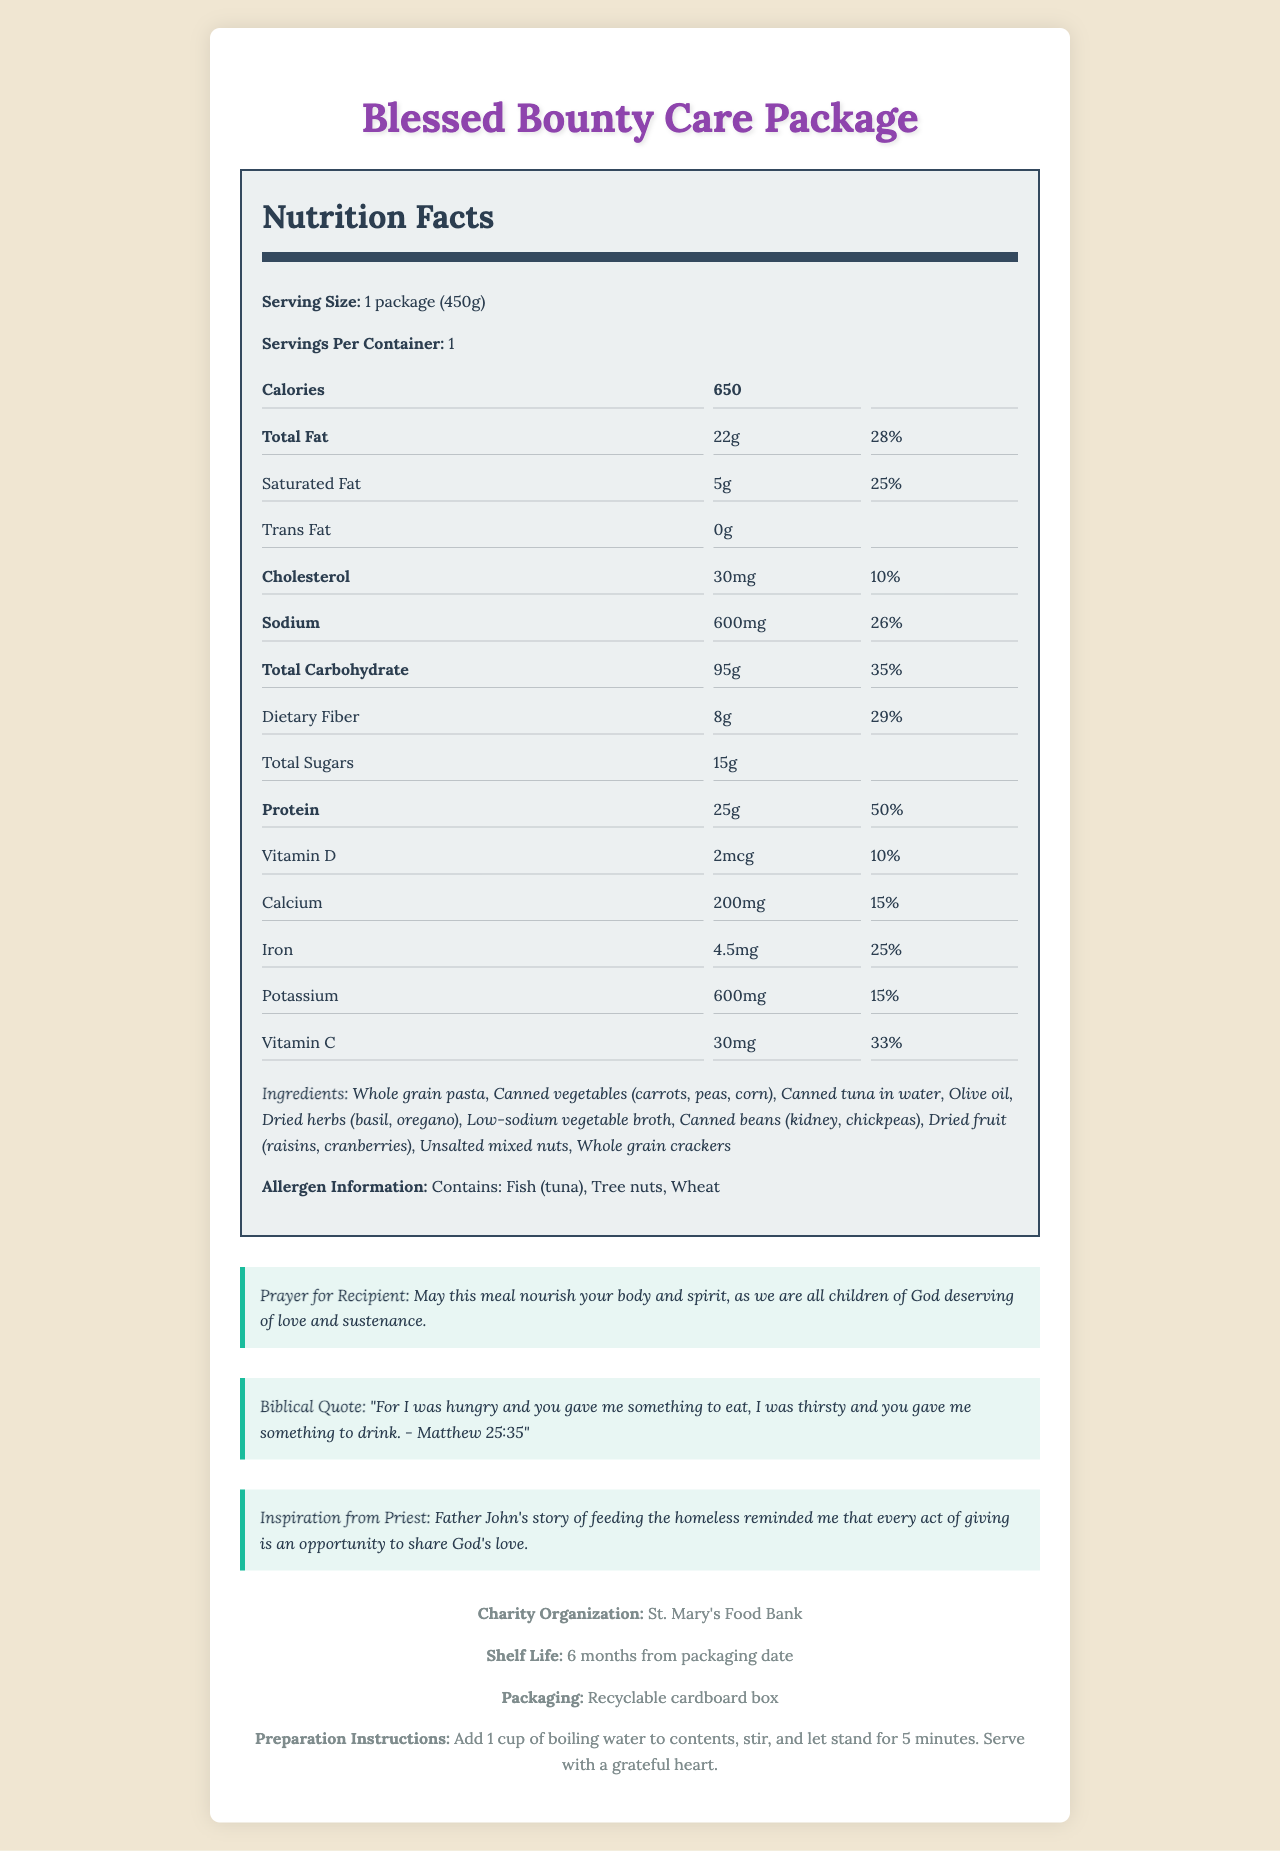what is the serving size of the Blessed Bounty Care Package? The serving size is stated as "1 package (450g)" in the document under the nutrition facts section.
Answer: 1 package (450g) how many calories are in one serving of the Blessed Bounty Care Package? The number of calories is listed as "650" under the nutrition facts section of the document.
Answer: 650 how much protein is in one serving of this care package? The total amount of protein is listed as "25g" with a daily value of "50%" in the nutrition facts section.
Answer: 25g what is the shelf life of the Blessed Bounty Care Package? The shelf life is mentioned as "6 months from packaging date" in the charity information section.
Answer: 6 months from the packaging date what is the source of inspiration behind this charitable act? The document states, "Inspiration from Priest: Father John's story of feeding the homeless reminded me that every act of giving is an opportunity to share God's love."
Answer: Father John's story of feeding the homeless which ingredient included in the care package might be of concern for individuals with fish allergies? A. Whole grain pasta B. Canned tuna in water C. Dried herbs (basil, oregano) D. Unsalted mixed nuts The ingredient list states that the package contains "Canned tuna in water," and the allergen information confirms it contains fish (tuna).
Answer: B what is the daily value percentage of saturated fat in one serving? The nutritional information states that the saturated fat amount is "5g" with a daily value of "25%".
Answer: 25% does the package include any dietary fiber? The document lists dietary fiber as "8g" with a daily value of "29%" in the nutrition facts section.
Answer: Yes what kinds of diet-related health benefits might this care package provide? The document lists detailed nutritional information showing it contains protein (25g), dietary fiber (8g), and various essential vitamins and minerals which are beneficial for health.
Answer: The package offers a good balance of macronutrients including significant amounts of protein, fiber, and vitamins. is the packaging of the Blessed Bounty Care Package eco-friendly? The document mentions that the packaging is made of "Recyclable cardboard box," indicating it is eco-friendly.
Answer: Yes summarize the main idea of the document. The document provides a detailed description of the care package's contents, nutritional information, and spiritual inspiration. It aims to nourish both the body and soul of the recipient while also promoting compassion and charity.
Answer: The Blessed Bounty Care Package is a nutritionally balanced meal designed as a charitable donation, inspired by Father John's story, aimed at nourishing recipients physically and spiritually. It contains a variety of ingredients, detailed nutritional information, a prayer, and a biblical quote, all organized by St. Mary's Food Bank. do we know the specific date of packaging for the Blessed Bounty Care Package? The document only indicates the shelf life as "6 months from packaging date" but does not provide the exact date of packaging.
Answer: Not enough information 